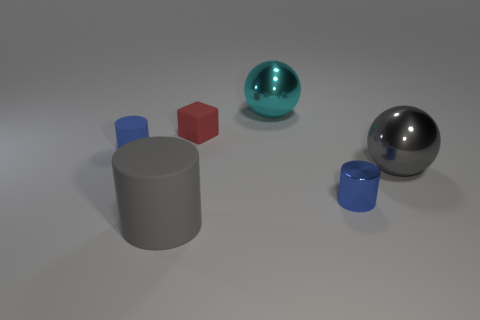There is a gray thing that is the same shape as the cyan object; what is it made of? The gray object that shares the same spherical shape as the cyan object appears to be made of a reflective metal, possibly steel or aluminum, as indicated by its shiny surface and reflections. 